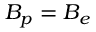<formula> <loc_0><loc_0><loc_500><loc_500>B _ { p } = B _ { e }</formula> 